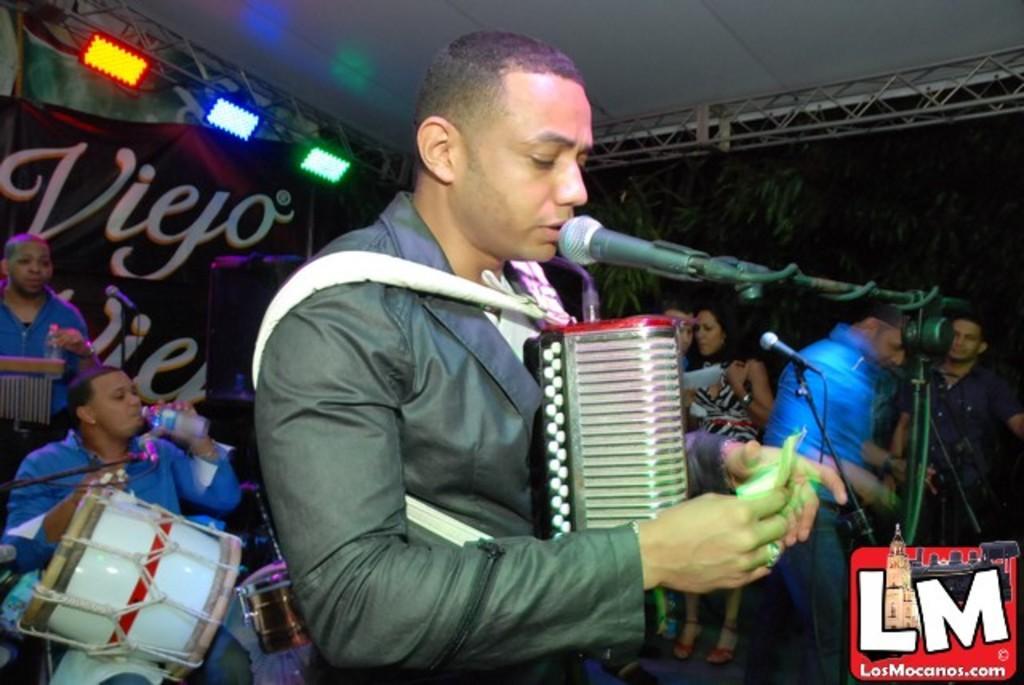Can you describe this image briefly? There is a man singing on the mike and he is drinking water. Here we can see few persons, mike's, musical instruments, and lights. In the background we can see a banner and trees. 